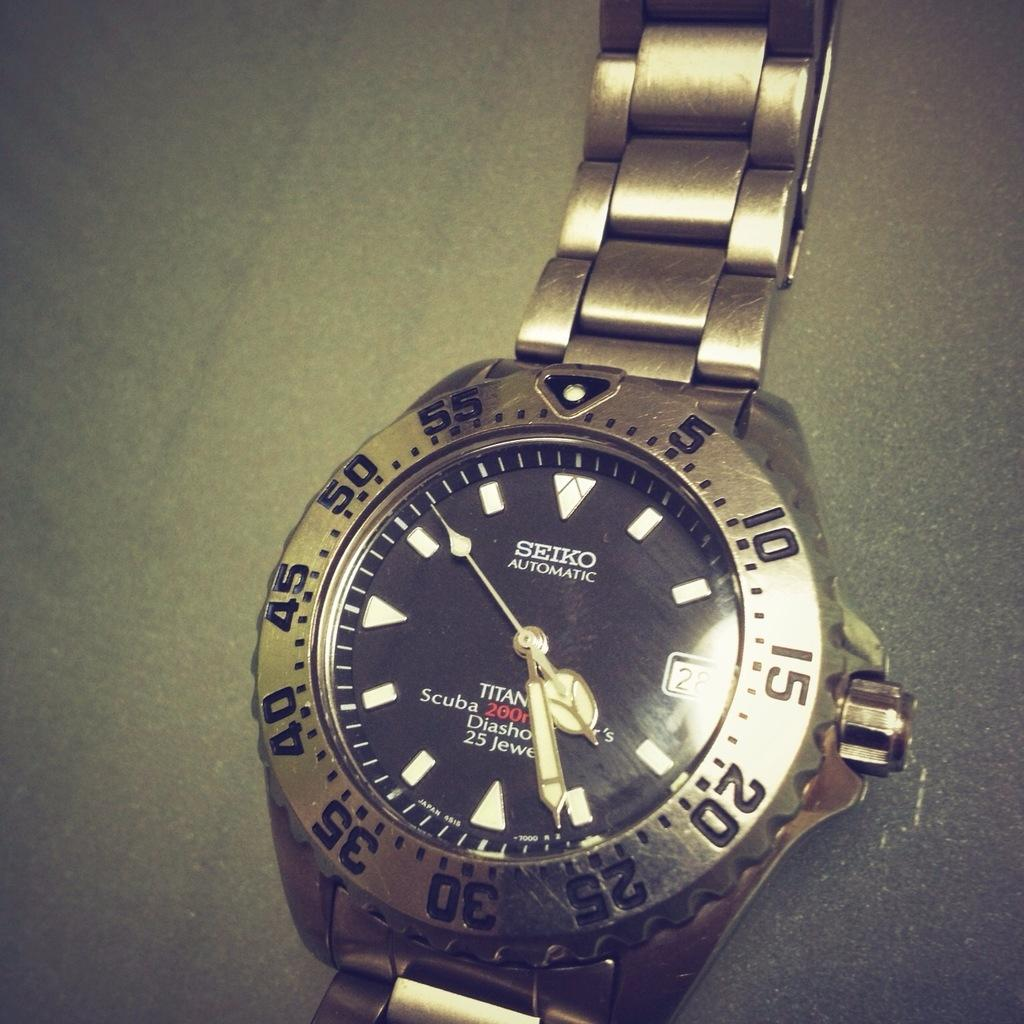<image>
Write a terse but informative summary of the picture. A silver SEIKO AUTOMATIC watch sits against a grey surface 